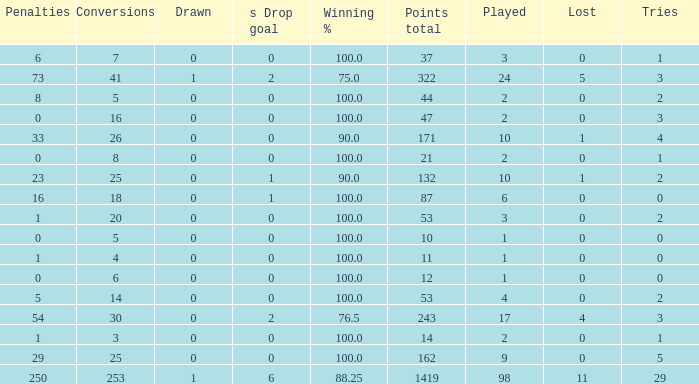How many ties did he have when he had 1 penalties and more than 20 conversions? None. 